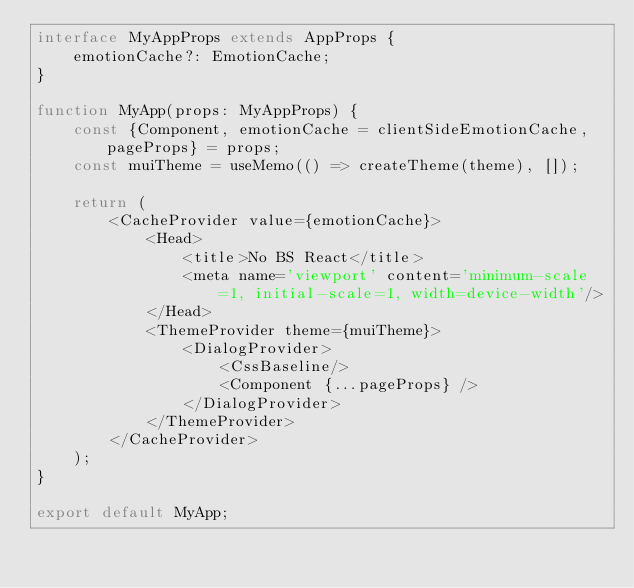Convert code to text. <code><loc_0><loc_0><loc_500><loc_500><_TypeScript_>interface MyAppProps extends AppProps {
    emotionCache?: EmotionCache;
}

function MyApp(props: MyAppProps) {
    const {Component, emotionCache = clientSideEmotionCache, pageProps} = props;
    const muiTheme = useMemo(() => createTheme(theme), []);

    return (
        <CacheProvider value={emotionCache}>
            <Head>
                <title>No BS React</title>
                <meta name='viewport' content='minimum-scale=1, initial-scale=1, width=device-width'/>
            </Head>
            <ThemeProvider theme={muiTheme}>
                <DialogProvider>
                    <CssBaseline/>
                    <Component {...pageProps} />
                </DialogProvider>
            </ThemeProvider>
        </CacheProvider>
    );
}

export default MyApp;
</code> 